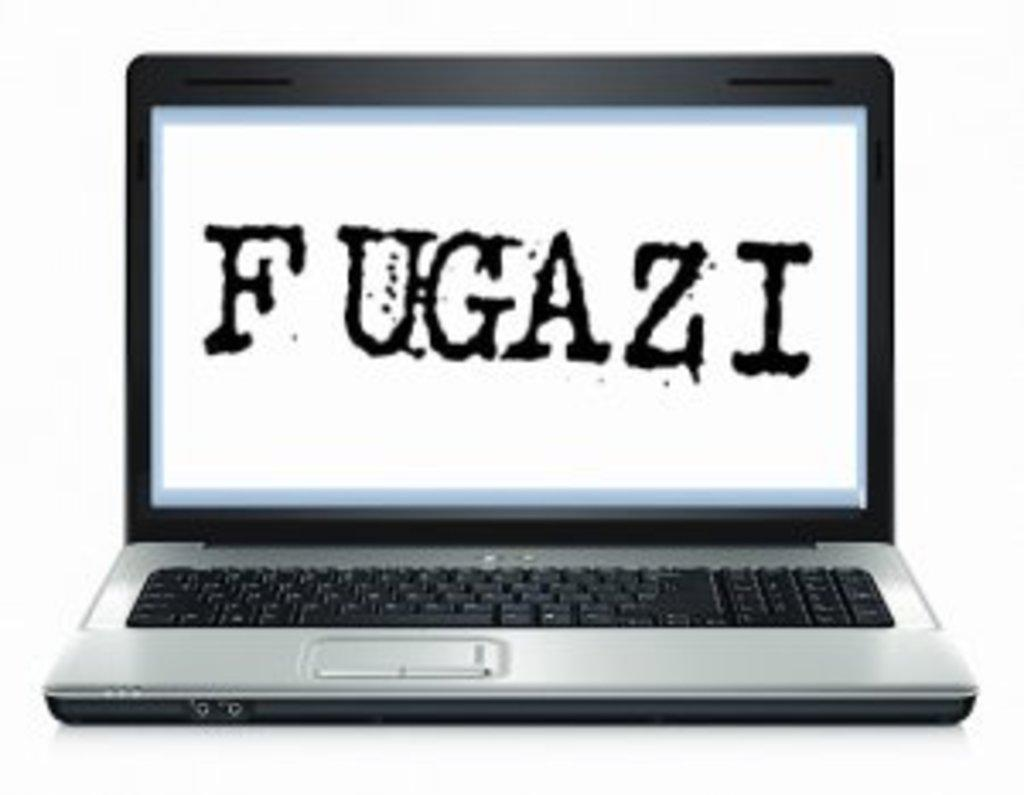<image>
Describe the image concisely. A laptop monitor that shows the word Fugazi 